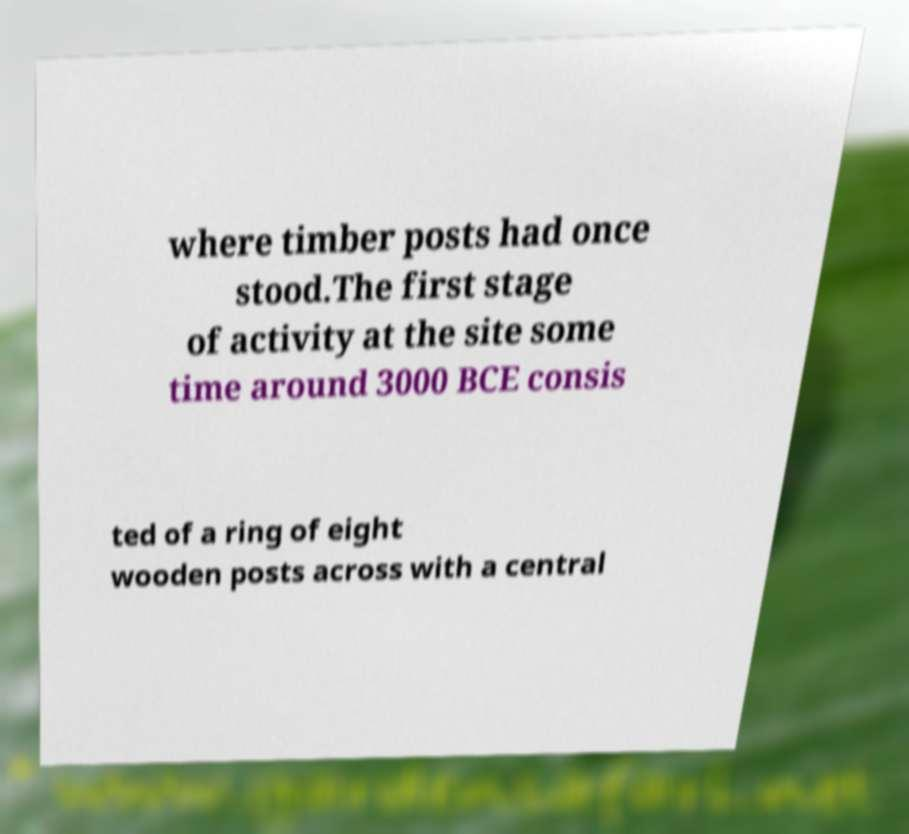For documentation purposes, I need the text within this image transcribed. Could you provide that? where timber posts had once stood.The first stage of activity at the site some time around 3000 BCE consis ted of a ring of eight wooden posts across with a central 